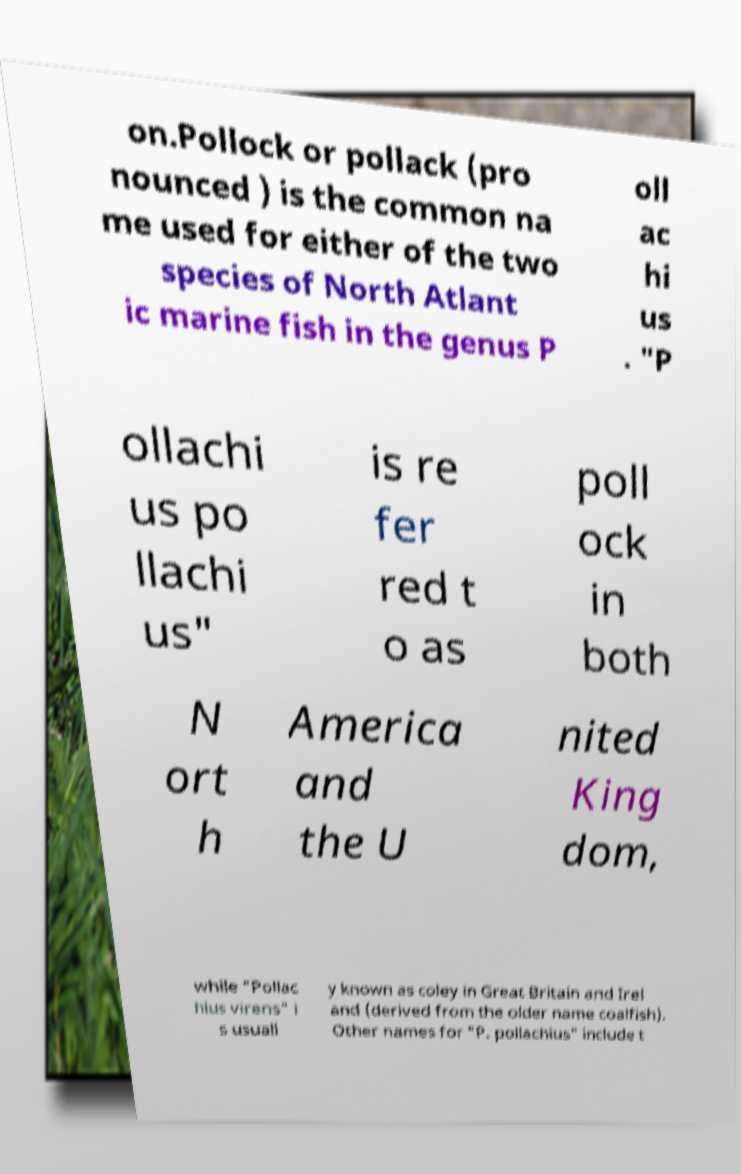For documentation purposes, I need the text within this image transcribed. Could you provide that? on.Pollock or pollack (pro nounced ) is the common na me used for either of the two species of North Atlant ic marine fish in the genus P oll ac hi us . "P ollachi us po llachi us" is re fer red t o as poll ock in both N ort h America and the U nited King dom, while "Pollac hius virens" i s usuall y known as coley in Great Britain and Irel and (derived from the older name coalfish). Other names for "P. pollachius" include t 